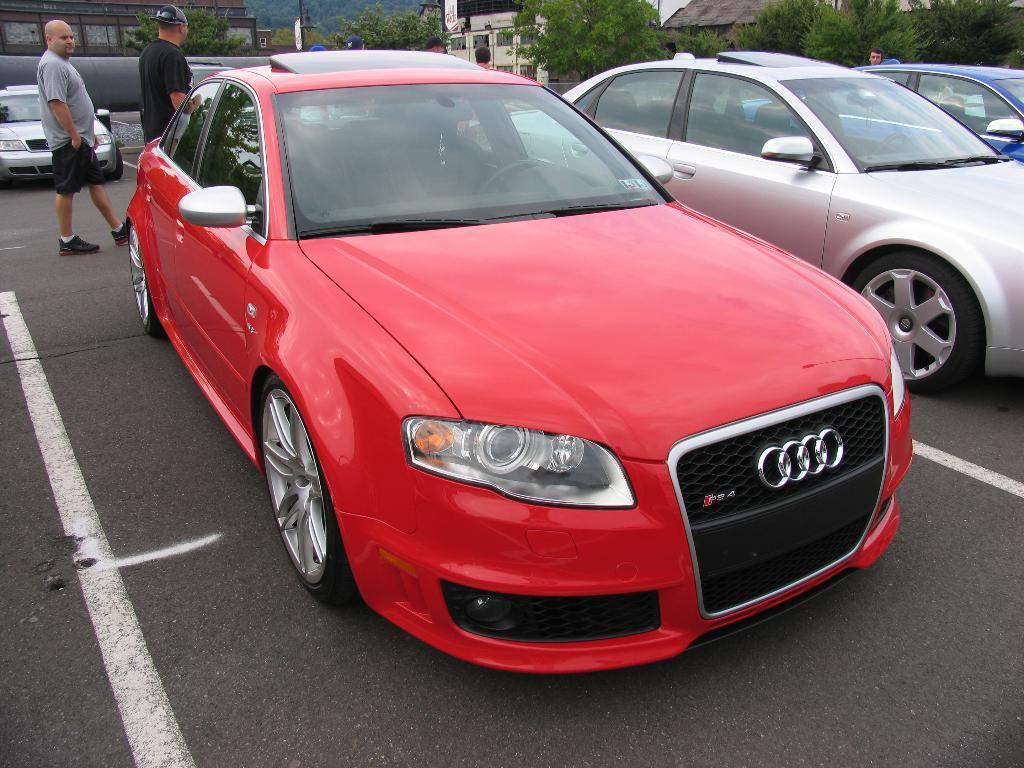Could you give a brief overview of what you see in this image? This picture is clicked outside the city. In this picture, we see four cars parked on the road. Behind that, we see a man in grey T-shirt and a man in black T-shirt is walking on the road. There are trees and buildings in the background. At the bottom of the picture, we see the road. 